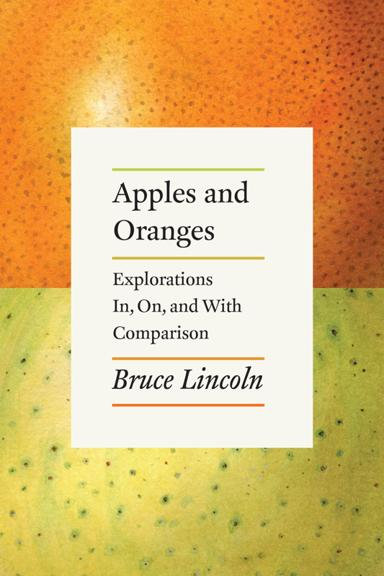What is the title of the book mentioned in the image? The title of the book shown in the image is 'Apples and Oranges: Explorations In, On, and With Comparison,' authored by Bruce Lincoln. The cover features a vivid, textured background that may symbolize the thematic contrast discussed in the book. 